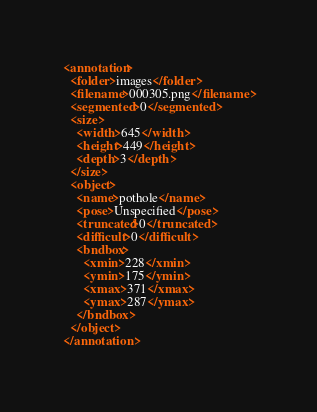Convert code to text. <code><loc_0><loc_0><loc_500><loc_500><_XML_><annotation>
  <folder>images</folder>
  <filename>000305.png</filename>
  <segmented>0</segmented>
  <size>
    <width>645</width>
    <height>449</height>
    <depth>3</depth>
  </size>
  <object>
    <name>pothole</name>
    <pose>Unspecified</pose>
    <truncated>0</truncated>
    <difficult>0</difficult>
    <bndbox>
      <xmin>228</xmin>
      <ymin>175</ymin>
      <xmax>371</xmax>
      <ymax>287</ymax>
    </bndbox>
  </object>
</annotation>
</code> 